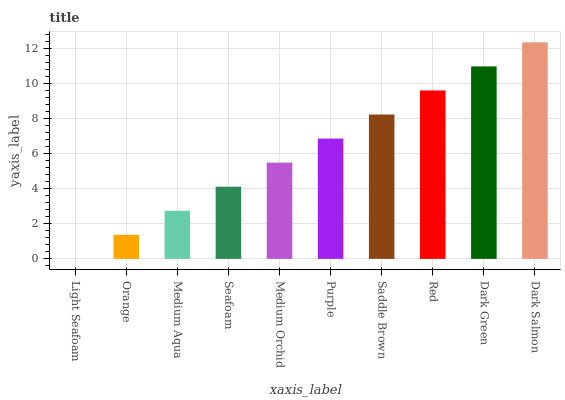Is Light Seafoam the minimum?
Answer yes or no. Yes. Is Dark Salmon the maximum?
Answer yes or no. Yes. Is Orange the minimum?
Answer yes or no. No. Is Orange the maximum?
Answer yes or no. No. Is Orange greater than Light Seafoam?
Answer yes or no. Yes. Is Light Seafoam less than Orange?
Answer yes or no. Yes. Is Light Seafoam greater than Orange?
Answer yes or no. No. Is Orange less than Light Seafoam?
Answer yes or no. No. Is Purple the high median?
Answer yes or no. Yes. Is Medium Orchid the low median?
Answer yes or no. Yes. Is Seafoam the high median?
Answer yes or no. No. Is Medium Aqua the low median?
Answer yes or no. No. 